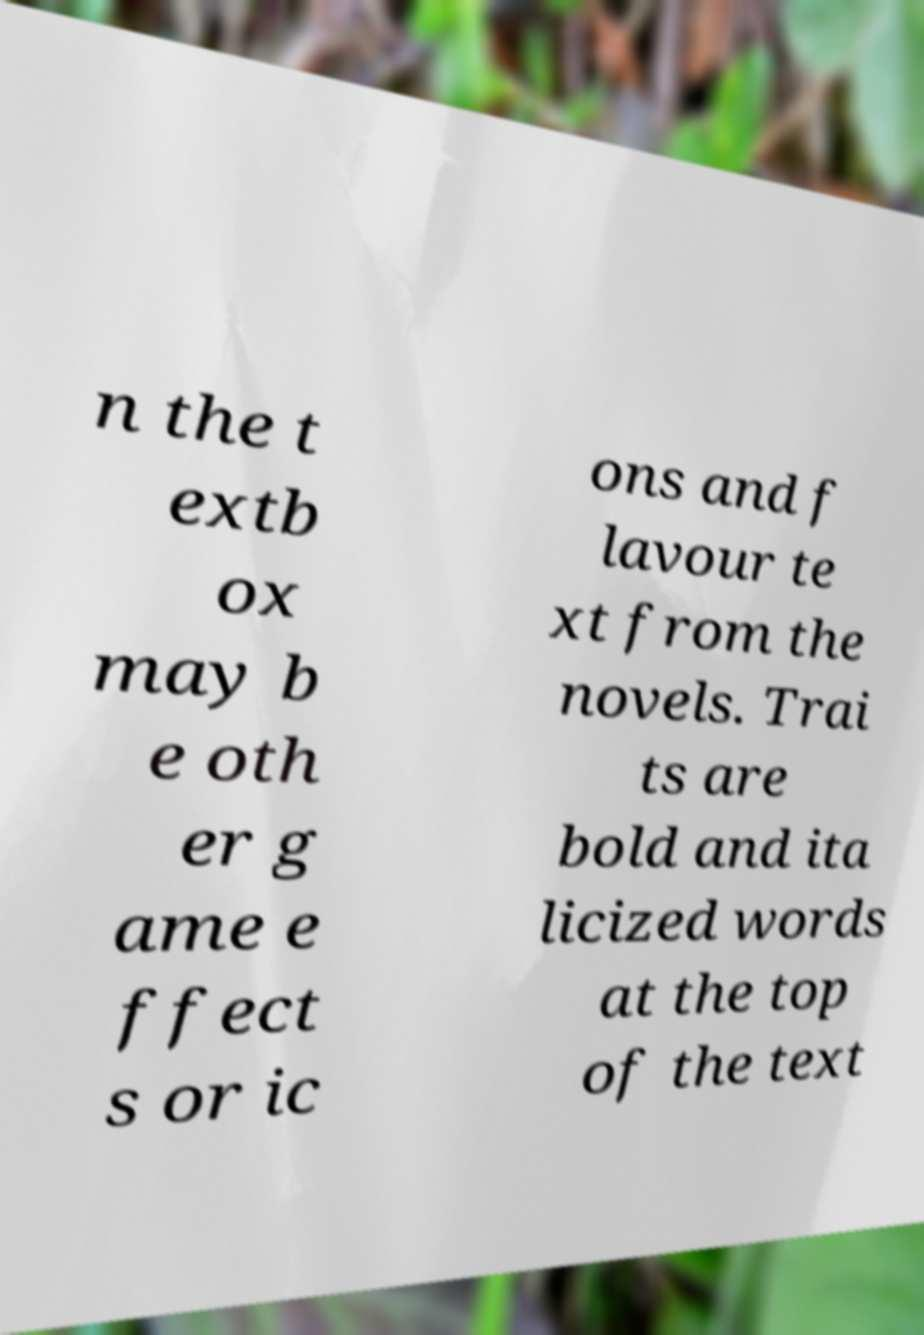Please identify and transcribe the text found in this image. n the t extb ox may b e oth er g ame e ffect s or ic ons and f lavour te xt from the novels. Trai ts are bold and ita licized words at the top of the text 